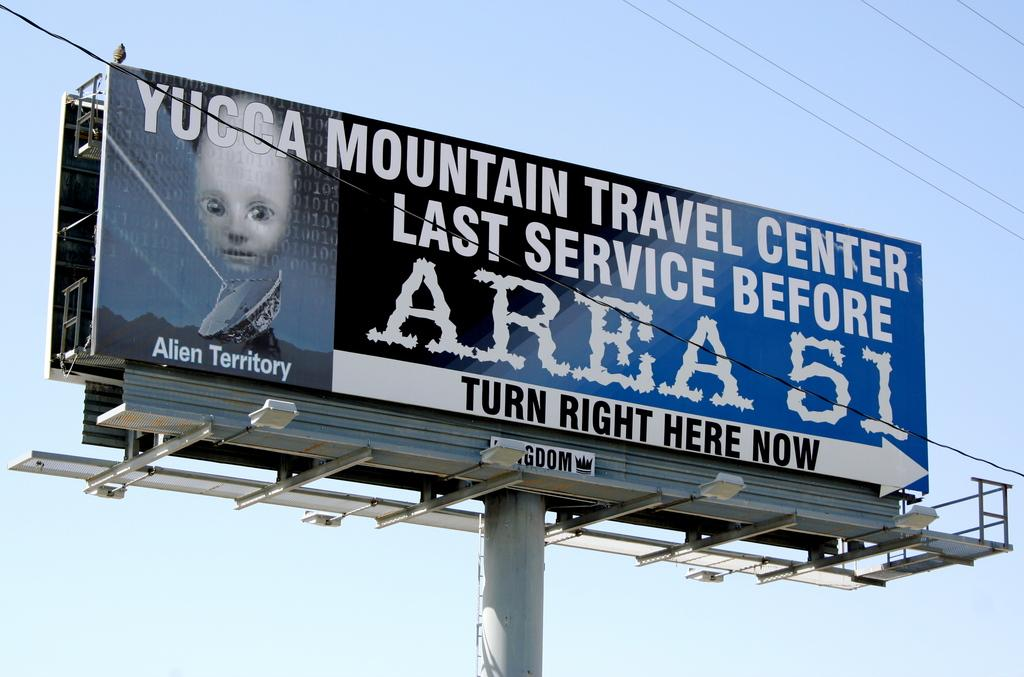<image>
Share a concise interpretation of the image provided. A billboard for Yucca Mountain Travel Center advertises itself as the Last Service Before Area 51. 